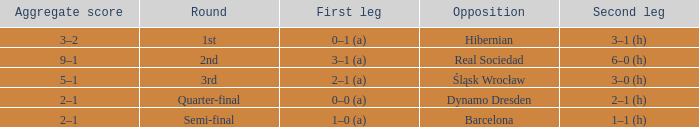Who were the opposition in the quarter-final? Dynamo Dresden. 